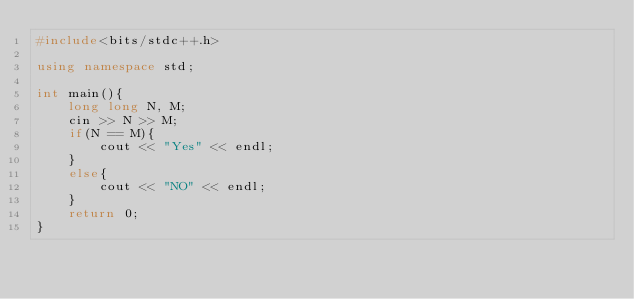<code> <loc_0><loc_0><loc_500><loc_500><_C++_>#include<bits/stdc++.h>

using namespace std;

int main(){
    long long N, M;
    cin >> N >> M;
    if(N == M){
        cout << "Yes" << endl;
    }
    else{
        cout << "NO" << endl;
    }
    return 0;
}</code> 